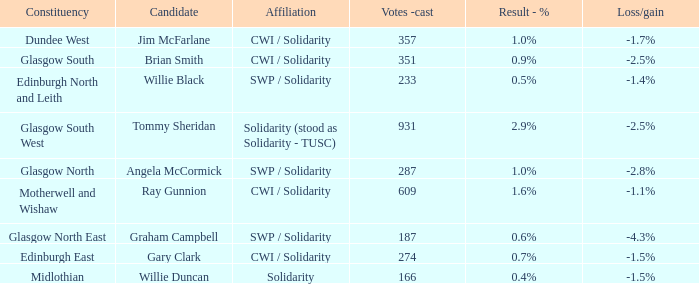Who was the contender when the result - % was Tommy Sheridan. 